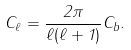Convert formula to latex. <formula><loc_0><loc_0><loc_500><loc_500>C _ { \ell } = \frac { 2 \pi } { \ell ( \ell + 1 ) } C _ { b } .</formula> 